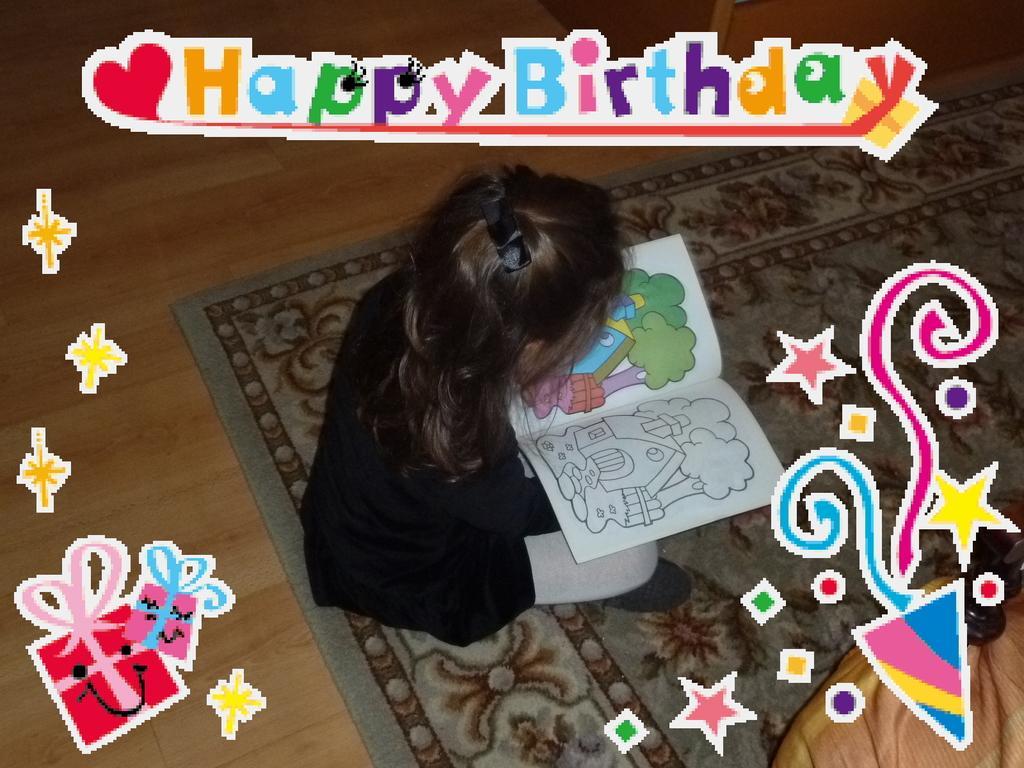Could you give a brief overview of what you see in this image? In this image, at the middle we can see a girl sitting on a carpet and she is holding a book, there is a brown color floor. 